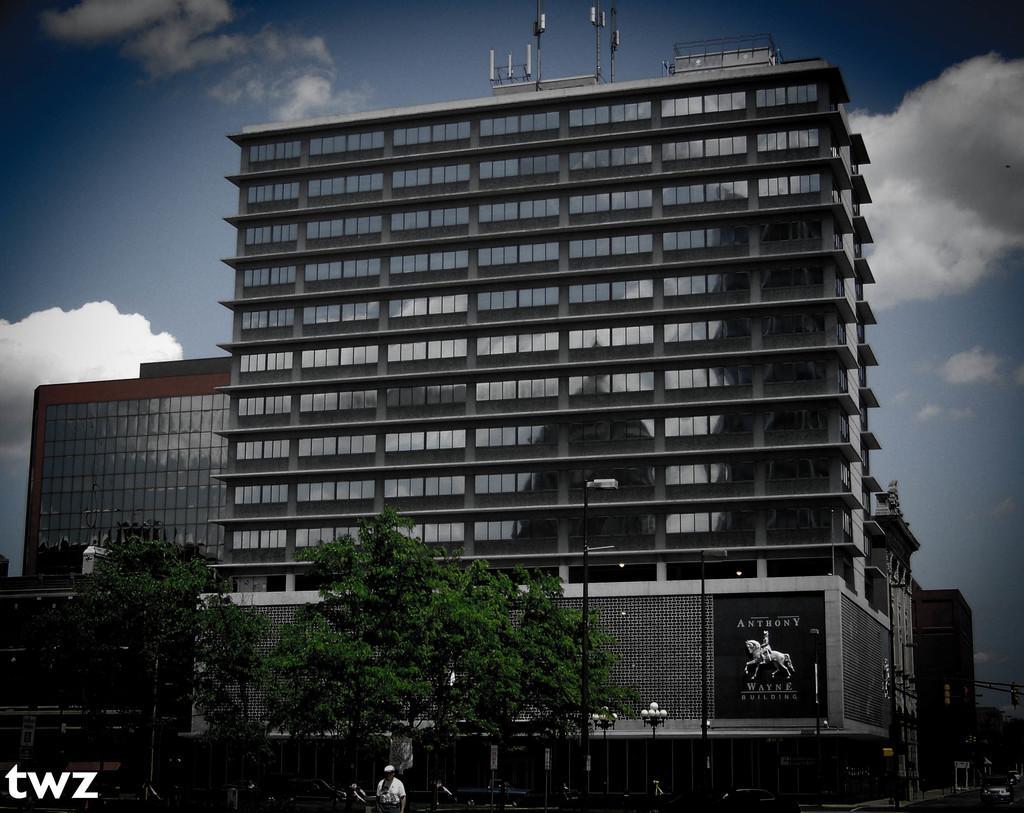Describe this image in one or two sentences. In this image there is a tall building in the middle. In front of the building there are trees. At the top there is the sky. At the bottom there is a road on which there are vehicles. There are poles with the lights on the footpath. There are so many glasses to the building. 